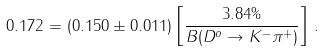Convert formula to latex. <formula><loc_0><loc_0><loc_500><loc_500>0 . 1 7 2 = ( 0 . 1 5 0 \pm 0 . 0 1 1 ) \left [ \frac { 3 . 8 4 \% } { B ( D ^ { o } \rightarrow K ^ { - } \pi ^ { + } ) } \right ] \, .</formula> 